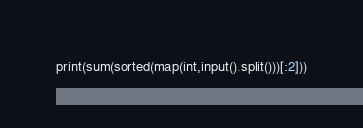Convert code to text. <code><loc_0><loc_0><loc_500><loc_500><_Python_>print(sum(sorted(map(int,input().split()))[:2]))</code> 